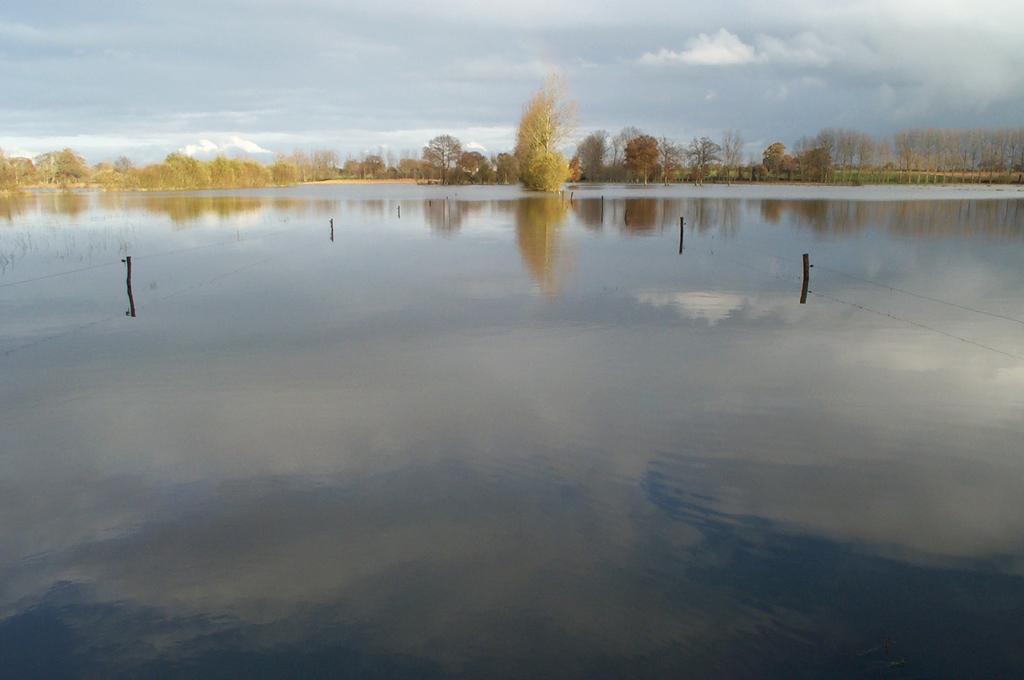Could you give a brief overview of what you see in this image? In the image we can see there is water, there are poles in the water and wires attached to the pole. Behind there are lot of trees and there is a cloudy sky. There is reflection of the sky is seen in the water. 